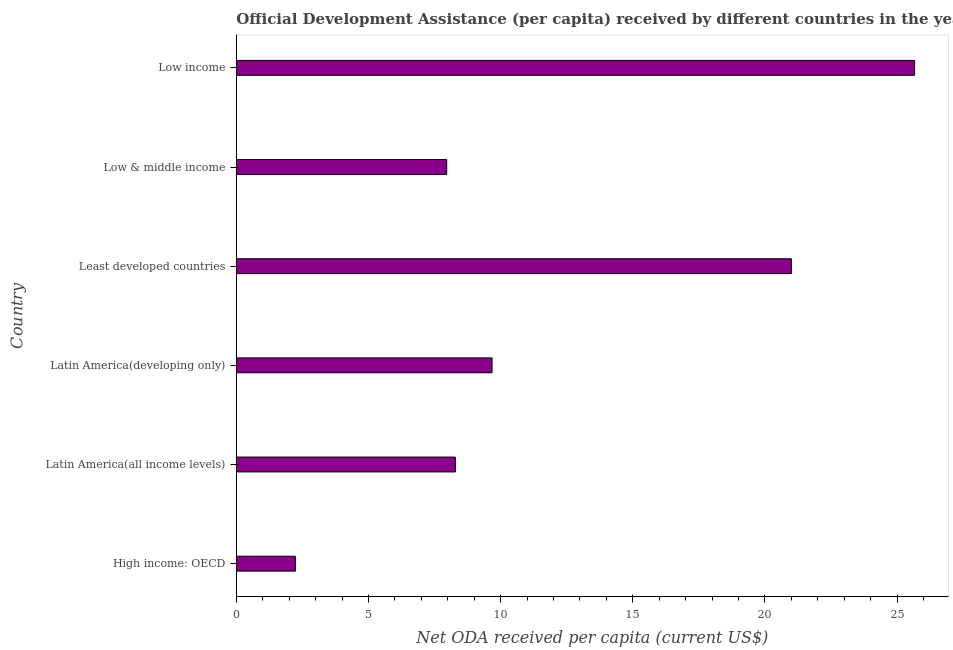Does the graph contain any zero values?
Provide a succinct answer. No. Does the graph contain grids?
Make the answer very short. No. What is the title of the graph?
Keep it short and to the point. Official Development Assistance (per capita) received by different countries in the year 1985. What is the label or title of the X-axis?
Your answer should be very brief. Net ODA received per capita (current US$). What is the net oda received per capita in Low income?
Your answer should be very brief. 25.66. Across all countries, what is the maximum net oda received per capita?
Offer a terse response. 25.66. Across all countries, what is the minimum net oda received per capita?
Provide a short and direct response. 2.24. In which country was the net oda received per capita maximum?
Offer a very short reply. Low income. In which country was the net oda received per capita minimum?
Your answer should be very brief. High income: OECD. What is the sum of the net oda received per capita?
Your answer should be very brief. 74.82. What is the difference between the net oda received per capita in Latin America(developing only) and Low & middle income?
Offer a very short reply. 1.72. What is the average net oda received per capita per country?
Your answer should be compact. 12.47. What is the median net oda received per capita?
Provide a succinct answer. 8.98. In how many countries, is the net oda received per capita greater than 25 US$?
Make the answer very short. 1. What is the ratio of the net oda received per capita in Latin America(developing only) to that in Low income?
Offer a very short reply. 0.38. Is the net oda received per capita in Latin America(developing only) less than that in Least developed countries?
Ensure brevity in your answer.  Yes. Is the difference between the net oda received per capita in High income: OECD and Latin America(all income levels) greater than the difference between any two countries?
Offer a terse response. No. What is the difference between the highest and the second highest net oda received per capita?
Keep it short and to the point. 4.66. Is the sum of the net oda received per capita in Least developed countries and Low income greater than the maximum net oda received per capita across all countries?
Give a very brief answer. Yes. What is the difference between the highest and the lowest net oda received per capita?
Provide a short and direct response. 23.42. In how many countries, is the net oda received per capita greater than the average net oda received per capita taken over all countries?
Offer a terse response. 2. Are all the bars in the graph horizontal?
Your response must be concise. Yes. What is the difference between two consecutive major ticks on the X-axis?
Provide a short and direct response. 5. Are the values on the major ticks of X-axis written in scientific E-notation?
Offer a terse response. No. What is the Net ODA received per capita (current US$) in High income: OECD?
Keep it short and to the point. 2.24. What is the Net ODA received per capita (current US$) of Latin America(all income levels)?
Provide a short and direct response. 8.29. What is the Net ODA received per capita (current US$) of Latin America(developing only)?
Ensure brevity in your answer.  9.68. What is the Net ODA received per capita (current US$) of Least developed countries?
Provide a succinct answer. 21. What is the Net ODA received per capita (current US$) of Low & middle income?
Your answer should be very brief. 7.96. What is the Net ODA received per capita (current US$) of Low income?
Offer a terse response. 25.66. What is the difference between the Net ODA received per capita (current US$) in High income: OECD and Latin America(all income levels)?
Provide a short and direct response. -6.05. What is the difference between the Net ODA received per capita (current US$) in High income: OECD and Latin America(developing only)?
Your answer should be very brief. -7.44. What is the difference between the Net ODA received per capita (current US$) in High income: OECD and Least developed countries?
Offer a terse response. -18.76. What is the difference between the Net ODA received per capita (current US$) in High income: OECD and Low & middle income?
Your answer should be very brief. -5.72. What is the difference between the Net ODA received per capita (current US$) in High income: OECD and Low income?
Your answer should be very brief. -23.42. What is the difference between the Net ODA received per capita (current US$) in Latin America(all income levels) and Latin America(developing only)?
Your answer should be very brief. -1.39. What is the difference between the Net ODA received per capita (current US$) in Latin America(all income levels) and Least developed countries?
Provide a short and direct response. -12.71. What is the difference between the Net ODA received per capita (current US$) in Latin America(all income levels) and Low & middle income?
Provide a short and direct response. 0.33. What is the difference between the Net ODA received per capita (current US$) in Latin America(all income levels) and Low income?
Your answer should be very brief. -17.37. What is the difference between the Net ODA received per capita (current US$) in Latin America(developing only) and Least developed countries?
Your response must be concise. -11.32. What is the difference between the Net ODA received per capita (current US$) in Latin America(developing only) and Low & middle income?
Your answer should be very brief. 1.72. What is the difference between the Net ODA received per capita (current US$) in Latin America(developing only) and Low income?
Offer a terse response. -15.98. What is the difference between the Net ODA received per capita (current US$) in Least developed countries and Low & middle income?
Your answer should be compact. 13.04. What is the difference between the Net ODA received per capita (current US$) in Least developed countries and Low income?
Ensure brevity in your answer.  -4.66. What is the difference between the Net ODA received per capita (current US$) in Low & middle income and Low income?
Give a very brief answer. -17.7. What is the ratio of the Net ODA received per capita (current US$) in High income: OECD to that in Latin America(all income levels)?
Your answer should be very brief. 0.27. What is the ratio of the Net ODA received per capita (current US$) in High income: OECD to that in Latin America(developing only)?
Offer a terse response. 0.23. What is the ratio of the Net ODA received per capita (current US$) in High income: OECD to that in Least developed countries?
Provide a succinct answer. 0.11. What is the ratio of the Net ODA received per capita (current US$) in High income: OECD to that in Low & middle income?
Your answer should be very brief. 0.28. What is the ratio of the Net ODA received per capita (current US$) in High income: OECD to that in Low income?
Offer a very short reply. 0.09. What is the ratio of the Net ODA received per capita (current US$) in Latin America(all income levels) to that in Latin America(developing only)?
Ensure brevity in your answer.  0.86. What is the ratio of the Net ODA received per capita (current US$) in Latin America(all income levels) to that in Least developed countries?
Provide a short and direct response. 0.4. What is the ratio of the Net ODA received per capita (current US$) in Latin America(all income levels) to that in Low & middle income?
Your answer should be compact. 1.04. What is the ratio of the Net ODA received per capita (current US$) in Latin America(all income levels) to that in Low income?
Offer a terse response. 0.32. What is the ratio of the Net ODA received per capita (current US$) in Latin America(developing only) to that in Least developed countries?
Offer a terse response. 0.46. What is the ratio of the Net ODA received per capita (current US$) in Latin America(developing only) to that in Low & middle income?
Give a very brief answer. 1.22. What is the ratio of the Net ODA received per capita (current US$) in Latin America(developing only) to that in Low income?
Your answer should be compact. 0.38. What is the ratio of the Net ODA received per capita (current US$) in Least developed countries to that in Low & middle income?
Offer a very short reply. 2.64. What is the ratio of the Net ODA received per capita (current US$) in Least developed countries to that in Low income?
Keep it short and to the point. 0.82. What is the ratio of the Net ODA received per capita (current US$) in Low & middle income to that in Low income?
Offer a terse response. 0.31. 